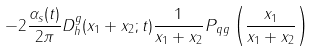<formula> <loc_0><loc_0><loc_500><loc_500>- 2 \frac { \alpha _ { s } ( t ) } { 2 \pi } D ^ { g } _ { h } ( x _ { 1 } + x _ { 2 } ; t ) \frac { 1 } { x _ { 1 } + x _ { 2 } } P _ { q g } \left ( \frac { x _ { 1 } } { x _ { 1 } + x _ { 2 } } \right )</formula> 